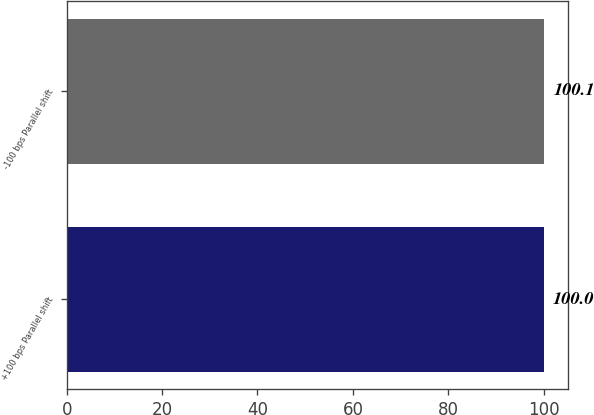Convert chart. <chart><loc_0><loc_0><loc_500><loc_500><bar_chart><fcel>+100 bps Parallel shift<fcel>-100 bps Parallel shift<nl><fcel>100<fcel>100.1<nl></chart> 